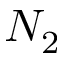Convert formula to latex. <formula><loc_0><loc_0><loc_500><loc_500>N _ { 2 }</formula> 